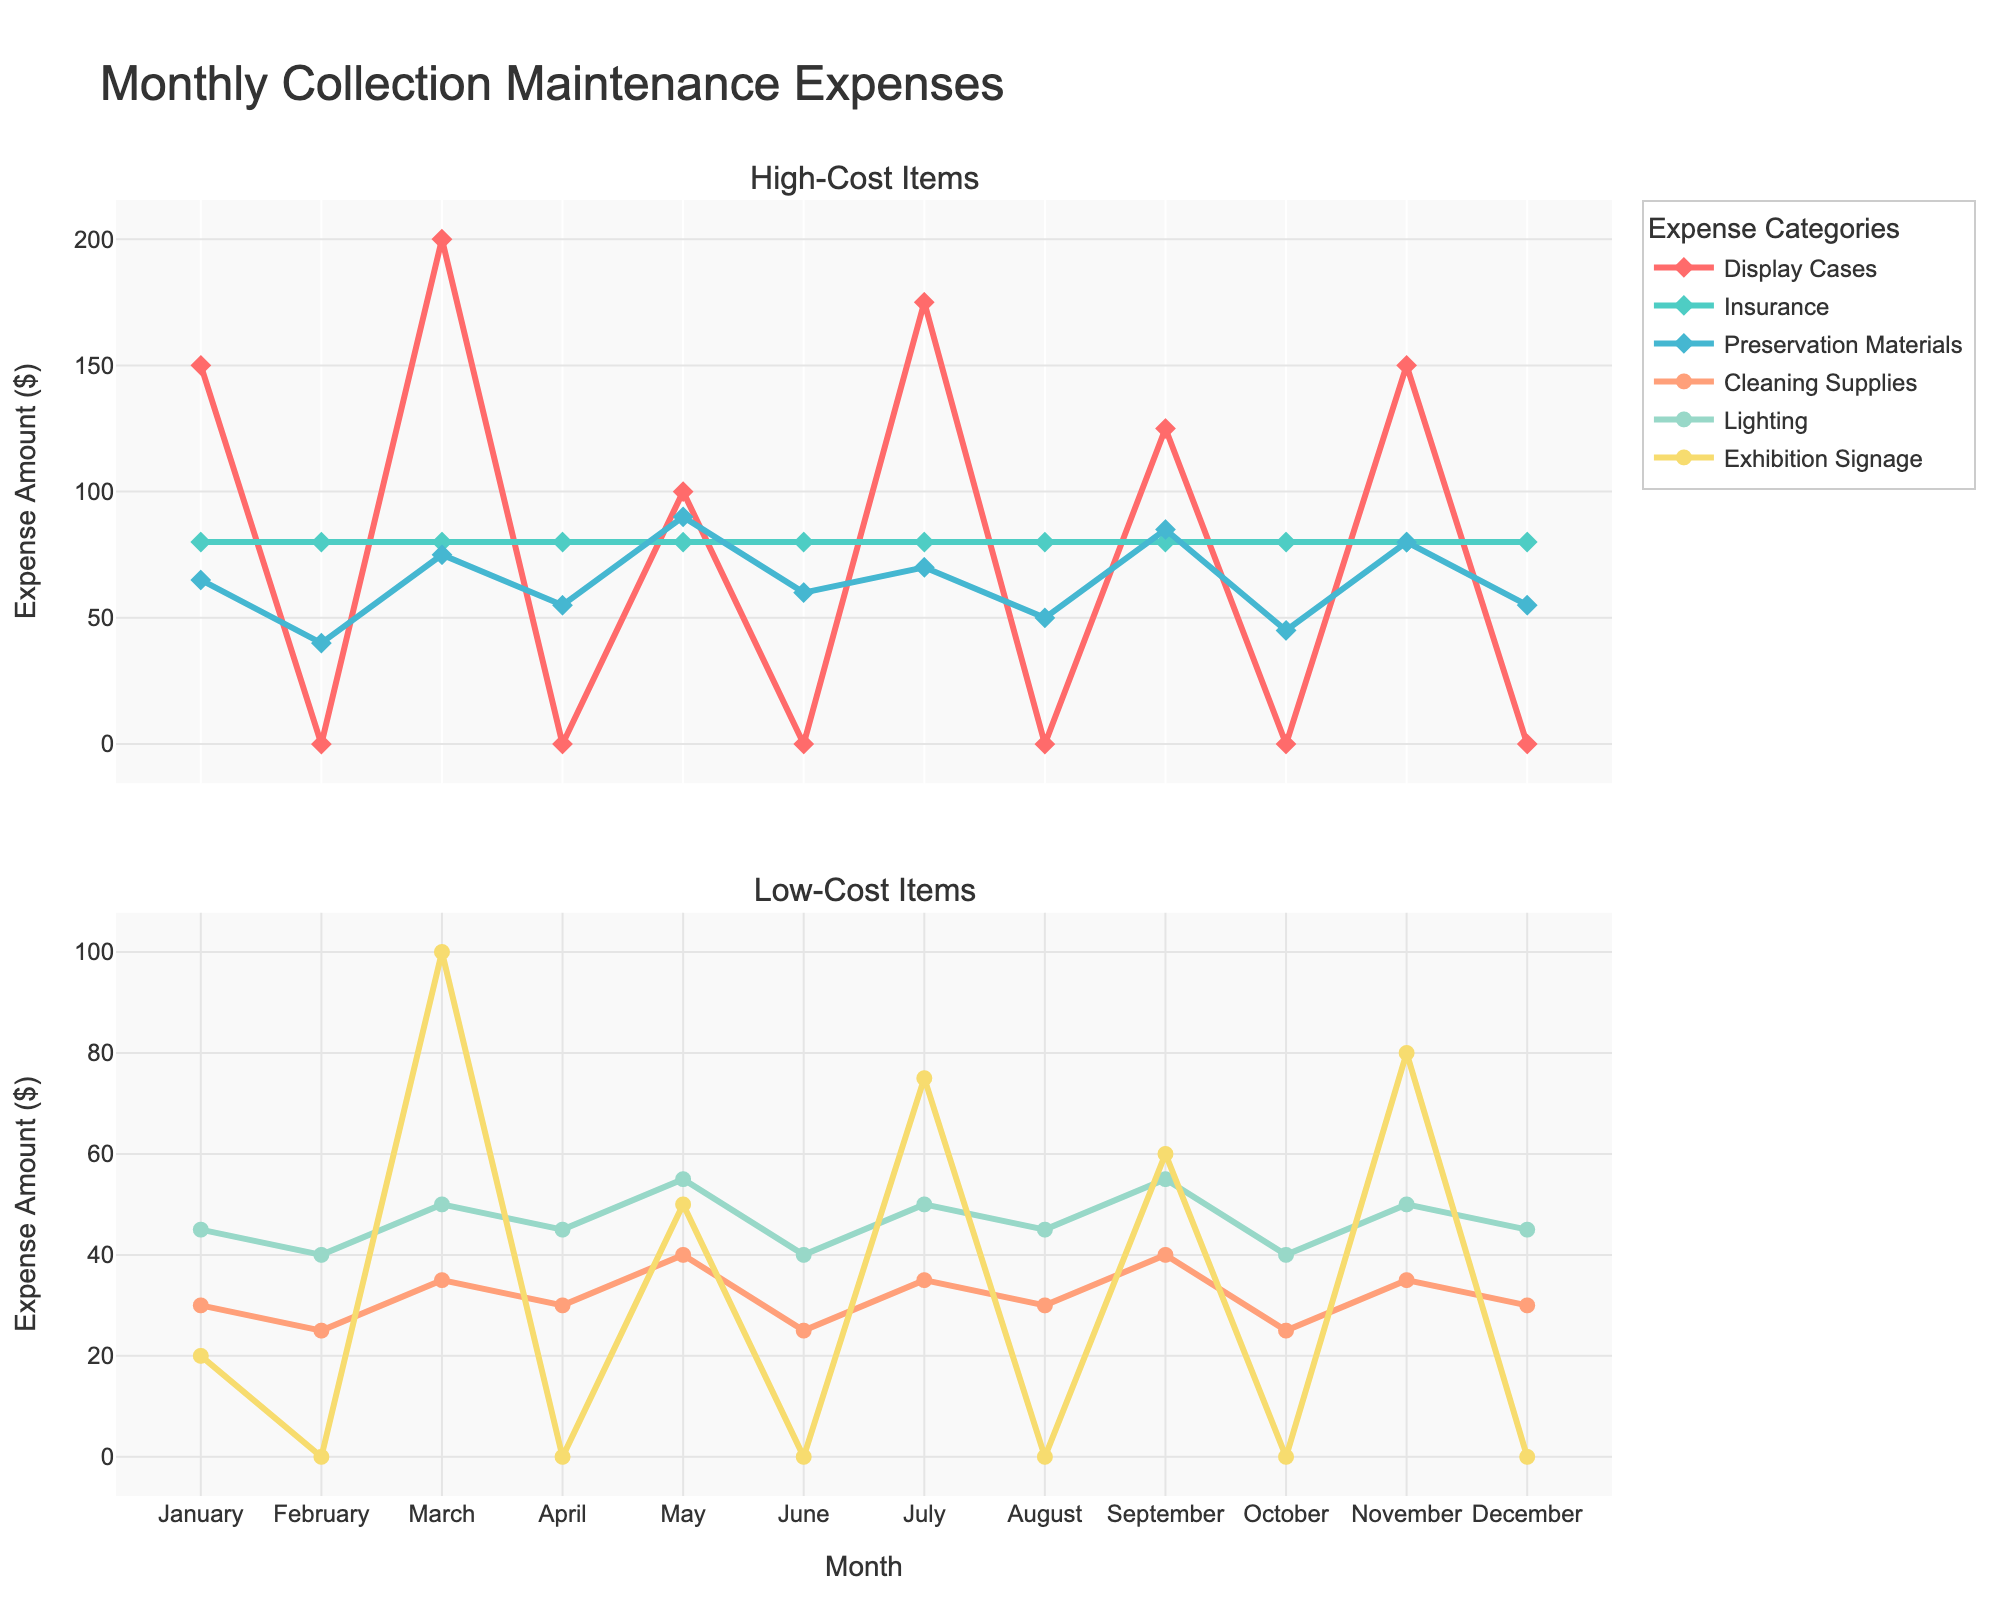What are the total expenses for Display Cases and Preservation Materials in March? In March, the expenses for Display Cases are $200, and for Preservation Materials, they are $75. Adding these together: $200 + $75 = $275.
Answer: $275 Which month had the highest expenditure on Exhibition Signage, and what was the amount? The months with non-zero data points for Exhibition Signage are March ($100), May ($50), July ($75), September ($60), and November ($80). The highest is in March with $100.
Answer: March, $100 During which month(s) did we spend nothing on Display Cases? Looking at the Display Cases line, the months with $0 spending are February, April, June, August, October, and December.
Answer: February, April, June, August, October, December Which category has consistent monthly expenses and what are they? The category "Insurance" has the same expense amount for each month, which is $80. This is seen as a constant line at $80 across all months.
Answer: Insurance, $80 What is the average monthly expense for Cleaning Supplies? The expenses for Cleaning Supplies in each month are (30, 25, 35, 30, 40, 25, 35, 30, 40, 25, 35, 30). Adding these: 30 + 25 + 35 + 30 + 40 + 25 + 35 + 30 + 40 + 25 + 35 + 30 = 380, and there are 12 months. So, 380 / 12 ≈ 31.67.
Answer: $31.67 Which category exhibited the most variability in expenses and why? By observing the different line patterns, Display Cases show significant fluctuations with some months at $0 and some going up to $200. This high variability is evident in the drastic up-down pattern of the Display Cases line.
Answer: Display Cases Compare the total expenses for high-cost items (Display Cases, Insurance, and Preservation Materials) between March and November. Which month had higher expenses and by how much? For March: Display Cases ($200) + Insurance ($80) + Preservation Materials ($75) = $355. For November: Display Cases ($150) + Insurance ($80) + Preservation Materials ($80) = $310. March had higher expenses by: $355 - $310 = $45.
Answer: March, $45 What are the total expenses for low-cost items in April? In April, the expenses for low-cost items are Cleaning Supplies ($30), Lighting ($45), and Exhibition Signage ($0). Summing these: $30 + $45 + $0 = $75.
Answer: $75 In which month was the expense for Lighting and Cleaning Supplies equal, and what was that amount? By comparing the lines for Lighting and Cleaning Supplies, in February they both have an expense of $40 and $25 respectively. No month matches exactly for Cleaning Supplies and Lighting.
Answer: None 